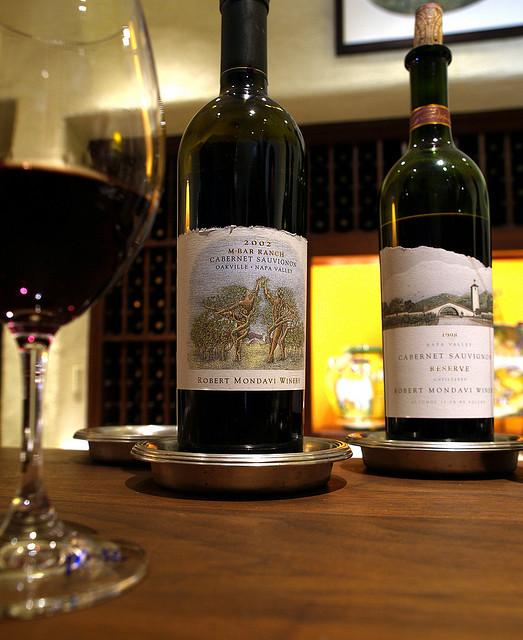Is this a picnic?
Concise answer only. No. Is the wine glass empty?
Answer briefly. No. Is this wine or beer?
Answer briefly. Wine. What animal is on the wine bottle?
Be succinct. None. 